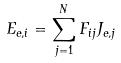<formula> <loc_0><loc_0><loc_500><loc_500>E _ { e , i } = \sum _ { j = 1 } ^ { N } F _ { i j } J _ { e , j }</formula> 